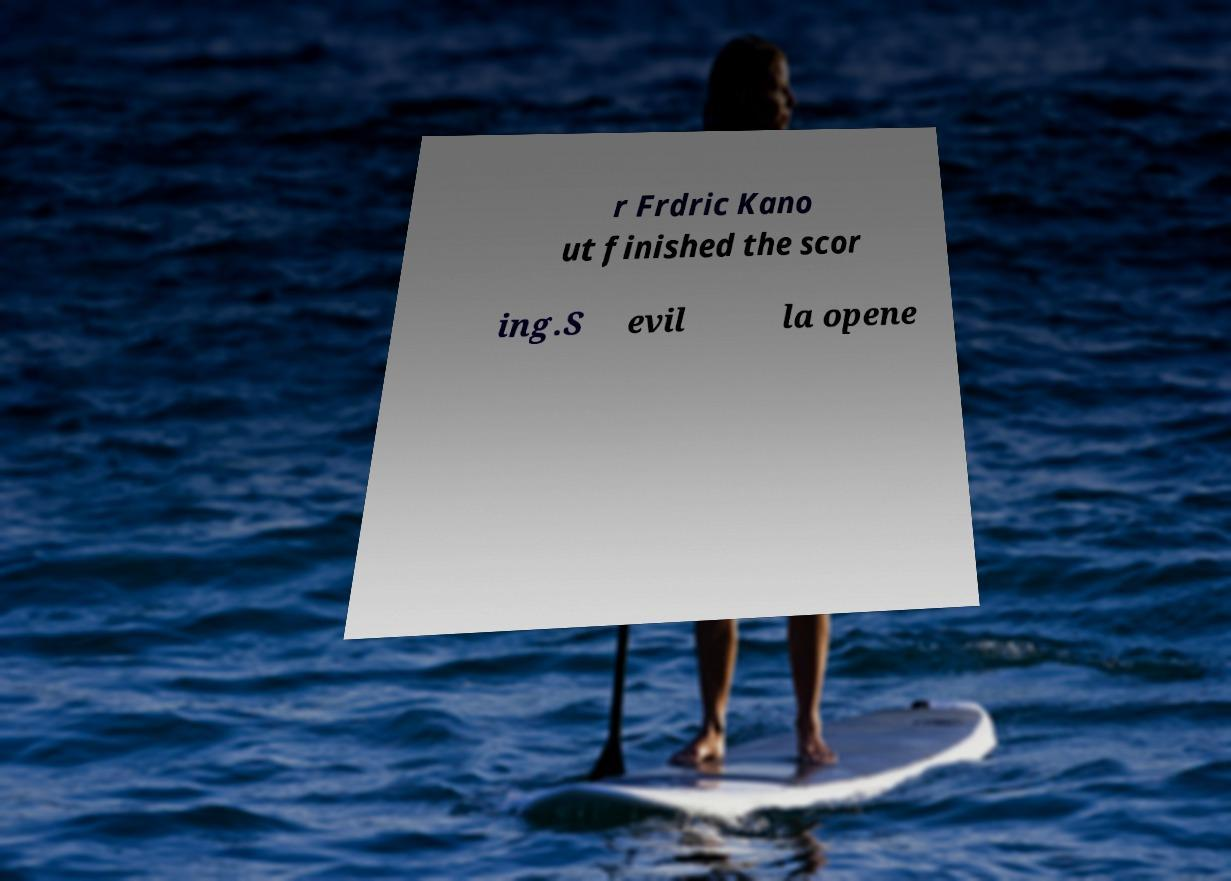Could you extract and type out the text from this image? r Frdric Kano ut finished the scor ing.S evil la opene 